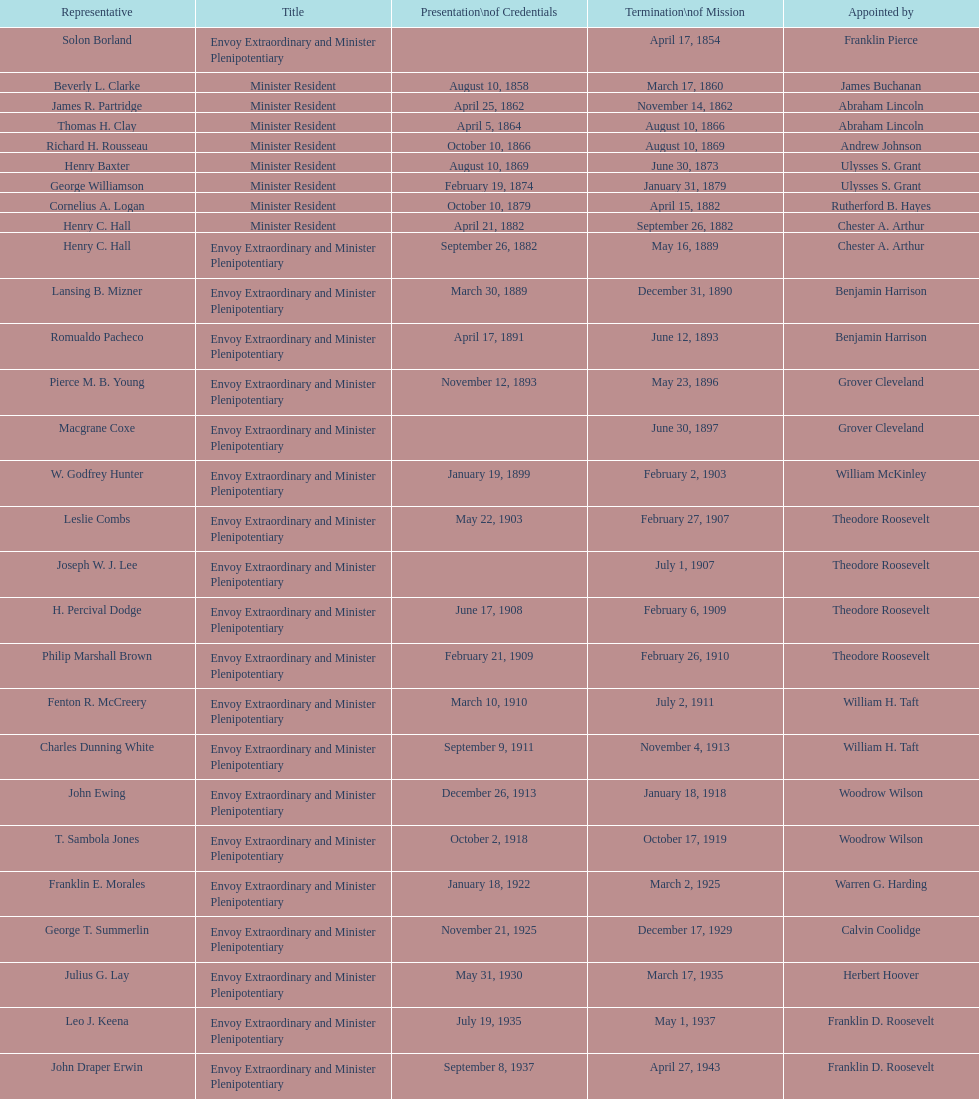What was the number of representatives appointed by theodore roosevelt? 4. 